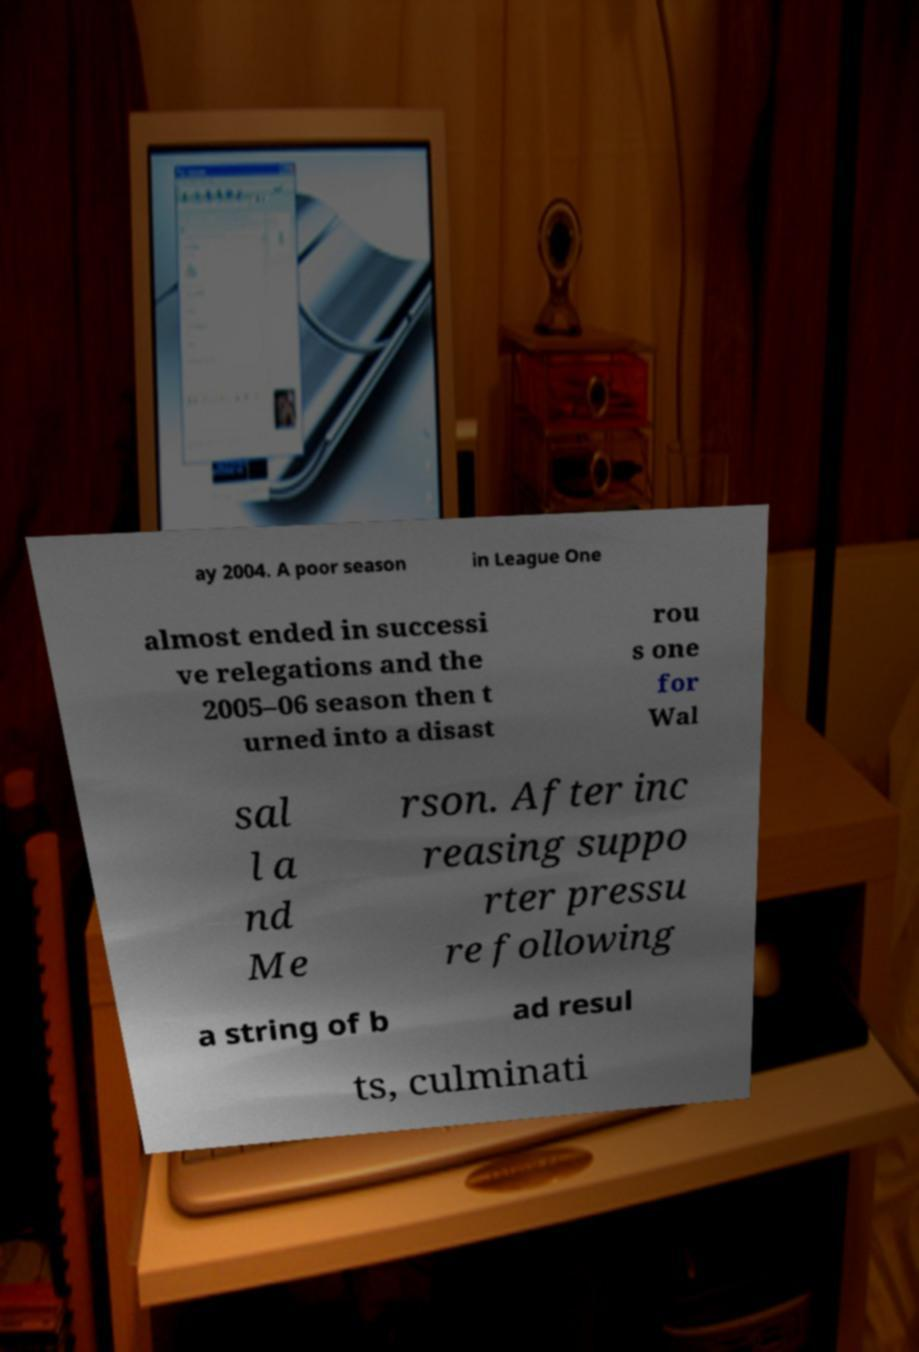Could you extract and type out the text from this image? ay 2004. A poor season in League One almost ended in successi ve relegations and the 2005–06 season then t urned into a disast rou s one for Wal sal l a nd Me rson. After inc reasing suppo rter pressu re following a string of b ad resul ts, culminati 